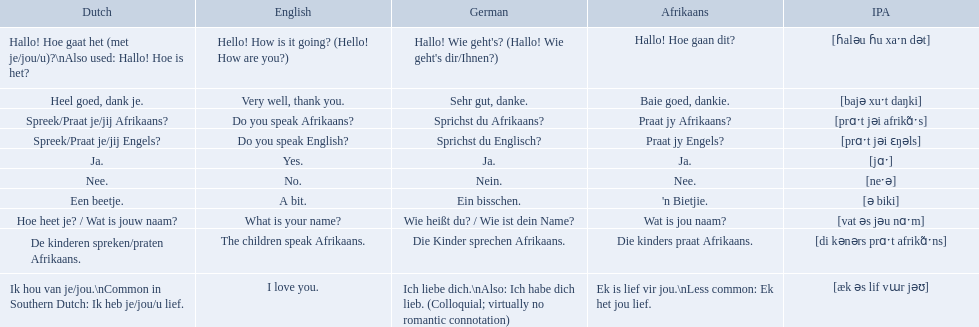How do you say do you speak english in german? Sprichst du Englisch?. What about do you speak afrikaanss? in afrikaans? Praat jy Afrikaans?. How do you say hello! how is it going? in afrikaans? Hallo! Hoe gaan dit?. How do you say very well, thank you in afrikaans? Baie goed, dankie. How would you say do you speak afrikaans? in afrikaans? Praat jy Afrikaans?. 